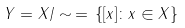<formula> <loc_0><loc_0><loc_500><loc_500>Y = X / \sim \, = \, \{ [ x ] \colon x \in X \}</formula> 